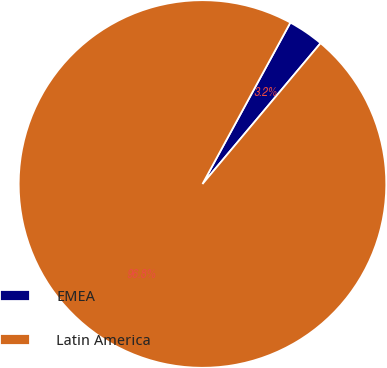Convert chart. <chart><loc_0><loc_0><loc_500><loc_500><pie_chart><fcel>EMEA<fcel>Latin America<nl><fcel>3.17%<fcel>96.83%<nl></chart> 